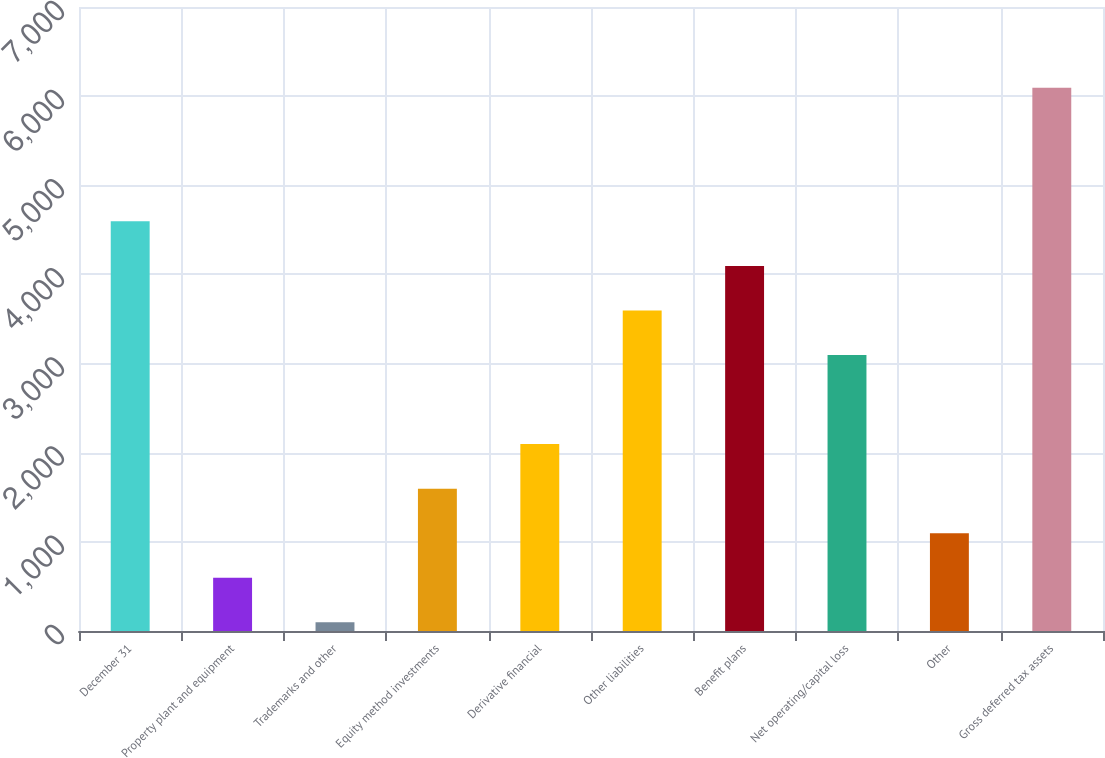Convert chart. <chart><loc_0><loc_0><loc_500><loc_500><bar_chart><fcel>December 31<fcel>Property plant and equipment<fcel>Trademarks and other<fcel>Equity method investments<fcel>Derivative financial<fcel>Other liabilities<fcel>Benefit plans<fcel>Net operating/capital loss<fcel>Other<fcel>Gross deferred tax assets<nl><fcel>4595.3<fcel>597.7<fcel>98<fcel>1597.1<fcel>2096.8<fcel>3595.9<fcel>4095.6<fcel>3096.2<fcel>1097.4<fcel>6094.4<nl></chart> 